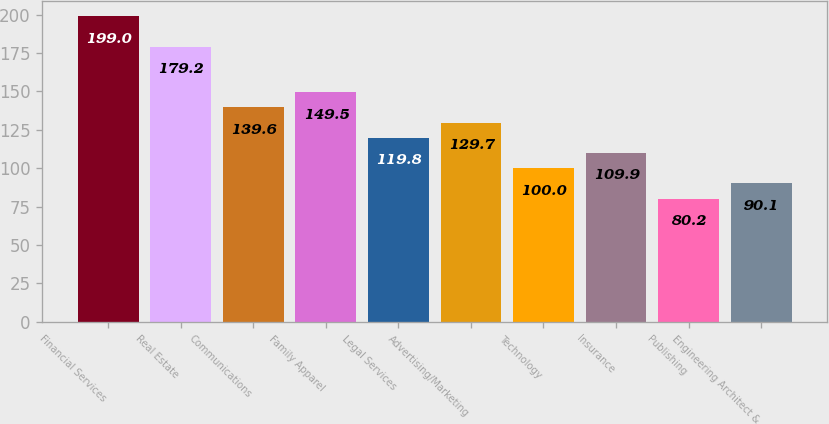Convert chart to OTSL. <chart><loc_0><loc_0><loc_500><loc_500><bar_chart><fcel>Financial Services<fcel>Real Estate<fcel>Communications<fcel>Family Apparel<fcel>Legal Services<fcel>Advertising/Marketing<fcel>Technology<fcel>Insurance<fcel>Publishing<fcel>Engineering Architect &<nl><fcel>199<fcel>179.2<fcel>139.6<fcel>149.5<fcel>119.8<fcel>129.7<fcel>100<fcel>109.9<fcel>80.2<fcel>90.1<nl></chart> 